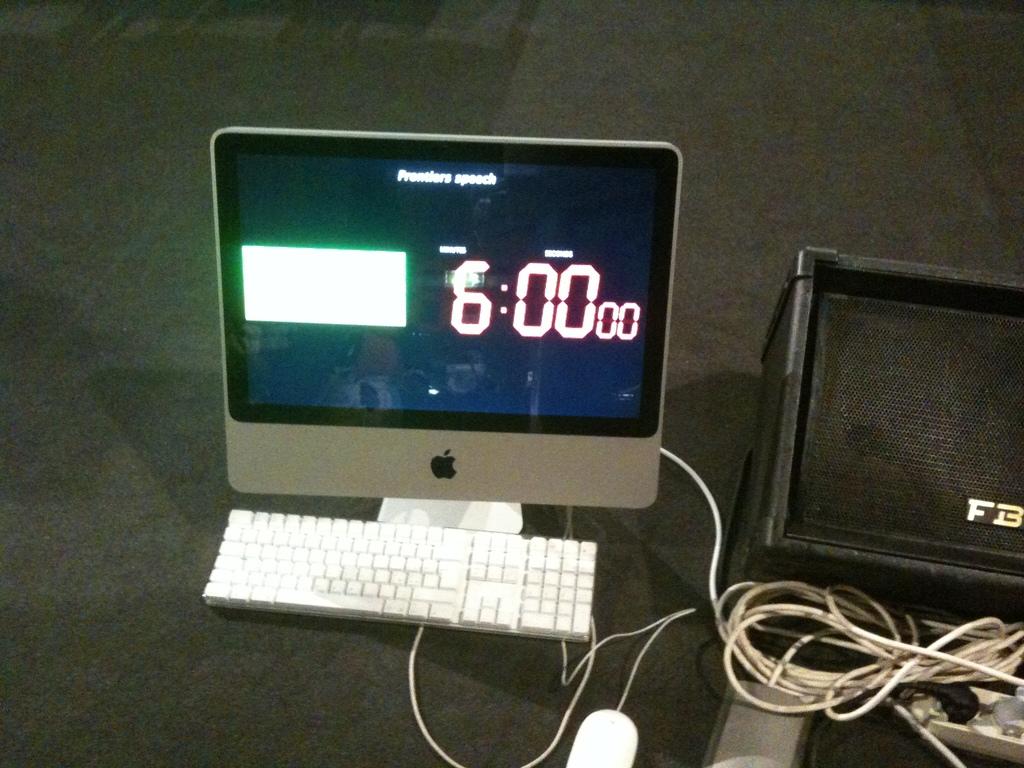How many minutes are shown on the timer?
Make the answer very short. 6. What are the two letters on the black speaker?
Your answer should be compact. Fb. 